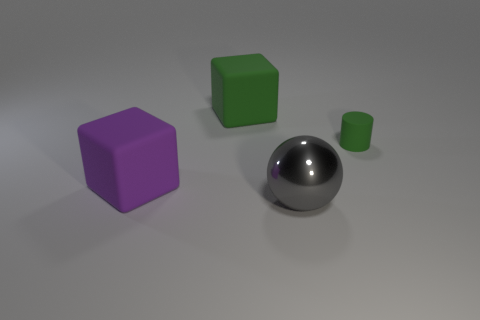Add 2 purple things. How many objects exist? 6 Subtract all cylinders. How many objects are left? 3 Subtract 1 gray spheres. How many objects are left? 3 Subtract all purple cylinders. Subtract all red spheres. How many cylinders are left? 1 Subtract all tiny gray metallic objects. Subtract all tiny green matte objects. How many objects are left? 3 Add 1 small objects. How many small objects are left? 2 Add 3 big purple metal things. How many big purple metal things exist? 3 